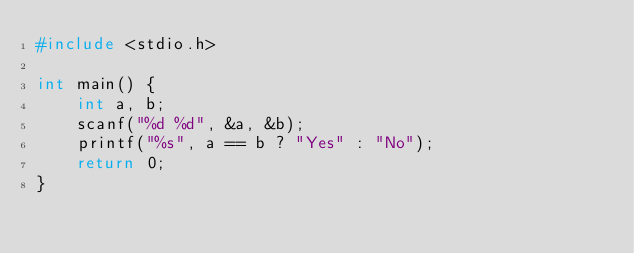<code> <loc_0><loc_0><loc_500><loc_500><_C_>#include <stdio.h>

int main() {
    int a, b;
    scanf("%d %d", &a, &b);
    printf("%s", a == b ? "Yes" : "No");
    return 0;
}</code> 